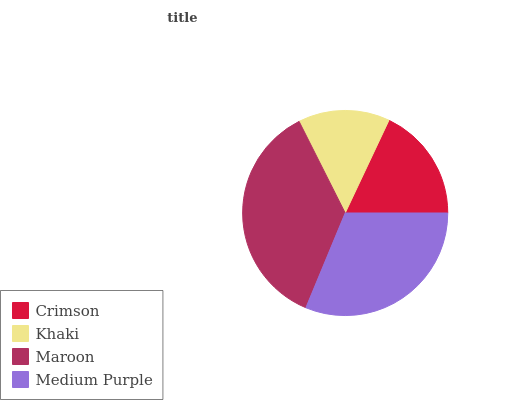Is Khaki the minimum?
Answer yes or no. Yes. Is Maroon the maximum?
Answer yes or no. Yes. Is Maroon the minimum?
Answer yes or no. No. Is Khaki the maximum?
Answer yes or no. No. Is Maroon greater than Khaki?
Answer yes or no. Yes. Is Khaki less than Maroon?
Answer yes or no. Yes. Is Khaki greater than Maroon?
Answer yes or no. No. Is Maroon less than Khaki?
Answer yes or no. No. Is Medium Purple the high median?
Answer yes or no. Yes. Is Crimson the low median?
Answer yes or no. Yes. Is Crimson the high median?
Answer yes or no. No. Is Medium Purple the low median?
Answer yes or no. No. 